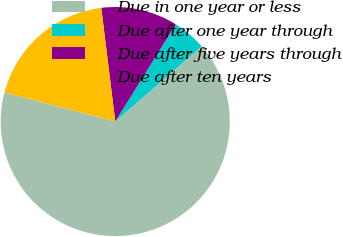<chart> <loc_0><loc_0><loc_500><loc_500><pie_chart><fcel>Due in one year or less<fcel>Due after one year through<fcel>Due after five years through<fcel>Due after ten years<nl><fcel>65.5%<fcel>4.73%<fcel>10.81%<fcel>18.96%<nl></chart> 